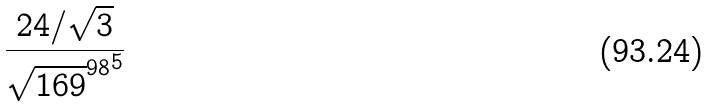Convert formula to latex. <formula><loc_0><loc_0><loc_500><loc_500>\frac { 2 4 / \sqrt { 3 } } { { \sqrt { 1 6 9 } ^ { 9 8 } } ^ { 5 } }</formula> 